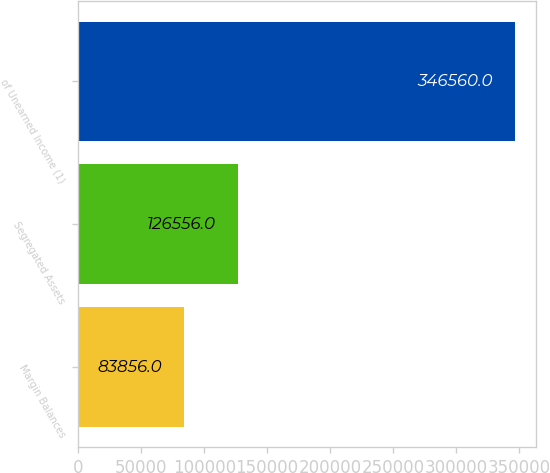Convert chart to OTSL. <chart><loc_0><loc_0><loc_500><loc_500><bar_chart><fcel>Margin Balances<fcel>Segregated Assets<fcel>of Unearned Income (1)<nl><fcel>83856<fcel>126556<fcel>346560<nl></chart> 